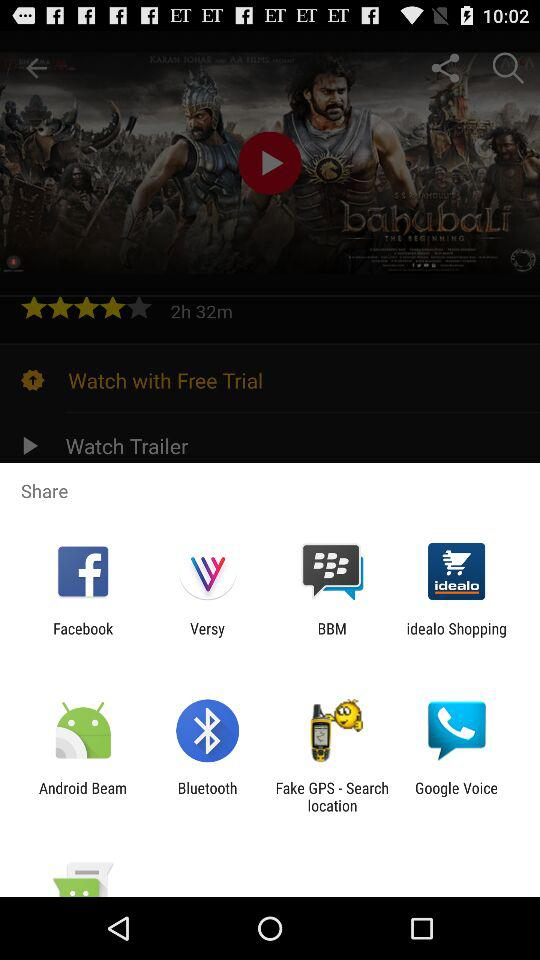What is the movie name? The movie name is "bahubaLi THE BEGINNING". 